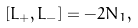Convert formula to latex. <formula><loc_0><loc_0><loc_500><loc_500>[ L _ { + } , L _ { - } ] = - 2 N _ { 1 } ,</formula> 